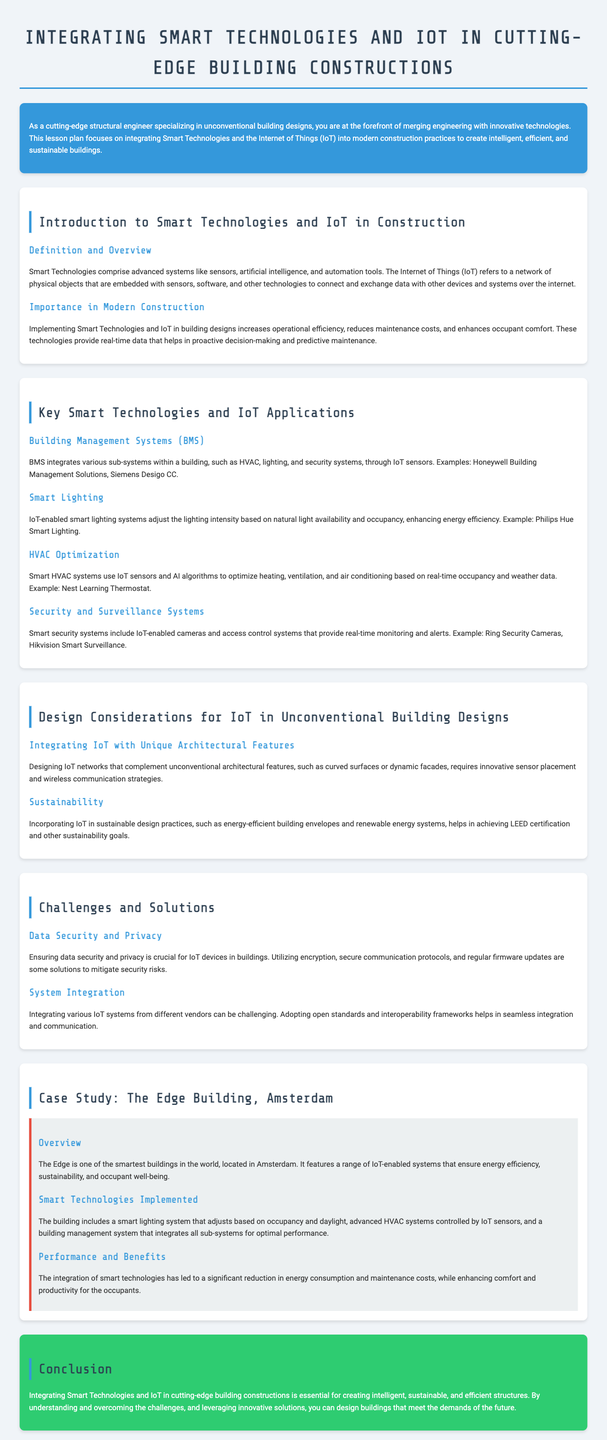What do Smart Technologies include? Smart Technologies comprise advanced systems like sensors, artificial intelligence, and automation tools.
Answer: sensors, artificial intelligence, automation tools What is the main benefit of implementing Smart Technologies and IoT in building designs? Implementing Smart Technologies and IoT increases operational efficiency, reduces maintenance costs, and enhances occupant comfort.
Answer: operational efficiency Name one example of Building Management Systems mentioned in the document. The document mentions Honeywell Building Management Solutions and Siemens Desigo CC as examples.
Answer: Honeywell Building Management Solutions What does IoT stand for? IoT refers to a network of physical objects that are embedded with sensors, software, and other technologies.
Answer: Internet of Things What is one challenge regarding IoT devices in buildings? Ensuring data security and privacy is crucial for IoT devices in buildings.
Answer: data security and privacy Which building is referred to as one of the smartest in the world? The Edge building in Amsterdam is referred to as one of the smartest buildings.
Answer: The Edge What type of systems does a smart lighting system adjust based on? IoT-enabled smart lighting systems adjust the lighting intensity based on natural light availability and occupancy.
Answer: natural light availability and occupancy What certification can be achieved by incorporating IoT in sustainable design practices? Incorporating IoT in sustainable design practices helps in achieving LEED certification.
Answer: LEED certification How does integrating smart technologies affect energy consumption? The integration of smart technologies has led to a significant reduction in energy consumption.
Answer: significant reduction 